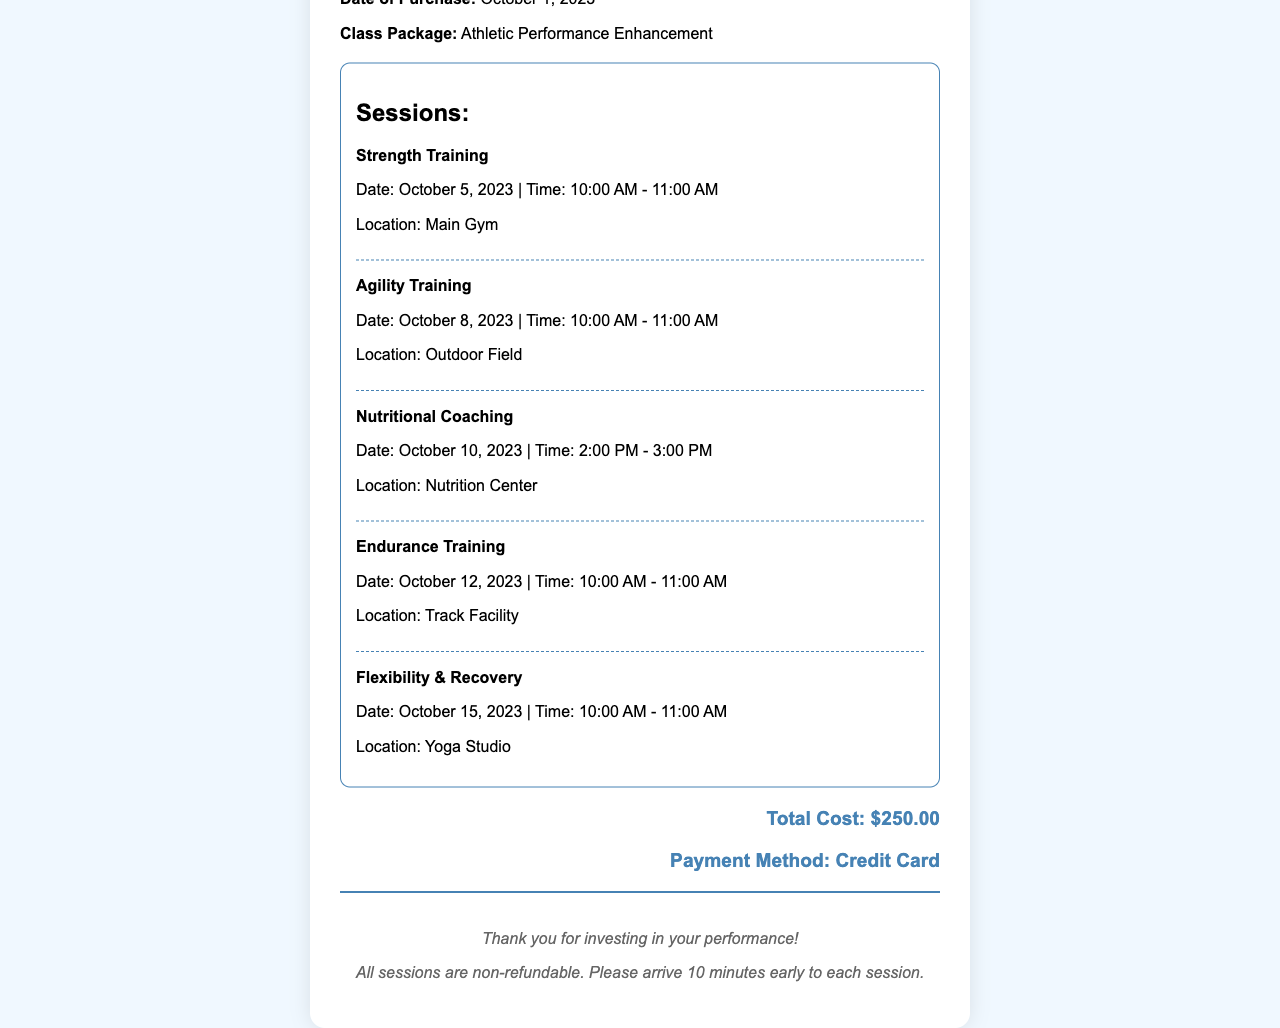What is the customer's name? The customer's name is written in the document under details.
Answer: Jordan Thompson What is the date of purchase? The purchase date is mentioned in the details section of the receipt.
Answer: October 1, 2023 How many sessions are included in the package? The number of sessions can be counted in the 'Sessions' section of the document.
Answer: 5 What is the total cost of the fitness class package? The total cost is provided at the bottom of the receipt.
Answer: $250.00 What type of training session is scheduled for October 8, 2023? The details about each session include the type and date of each session.
Answer: Agility Training Where is the Nutritional Coaching session held? The location for the Nutritional Coaching session is specified in its session details.
Answer: Nutrition Center What is the payment method used for the purchase? The payment method is mentioned in the total section of the receipt.
Answer: Credit Card How soon should customers arrive before each session? This information is included in the footer of the document.
Answer: 10 minutes early 